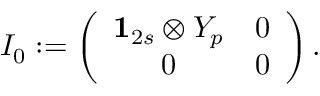Convert formula to latex. <formula><loc_0><loc_0><loc_500><loc_500>I _ { 0 } \colon = \left ( \begin{array} { c c } { { { 1 } _ { 2 s } \otimes Y _ { p } } } & { 0 } \\ { 0 } & { 0 } \end{array} \right ) .</formula> 